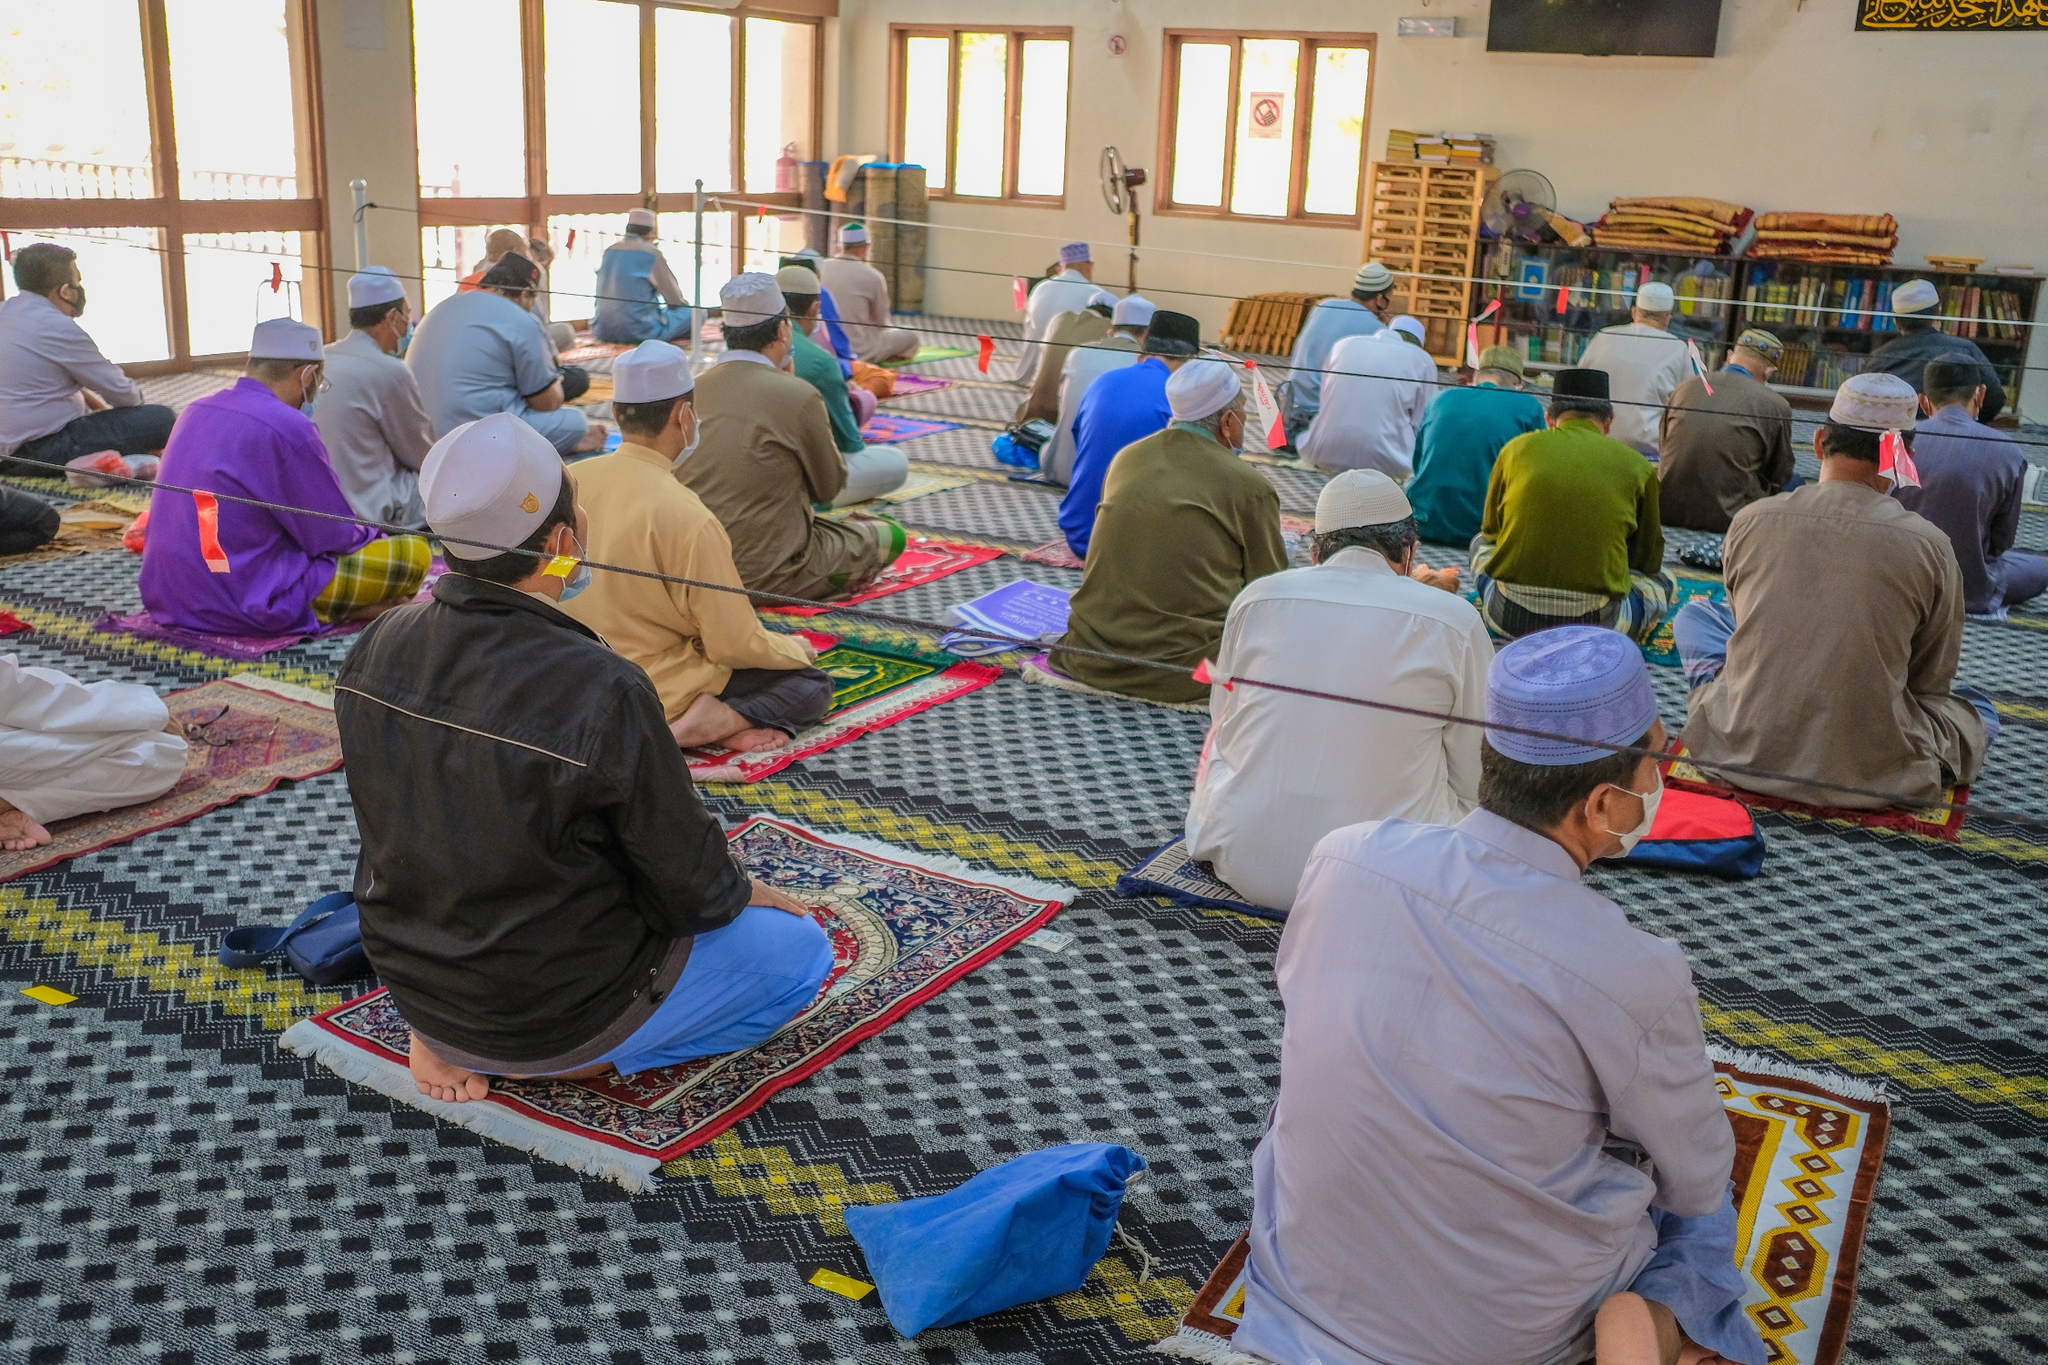What cultural significance can you draw from this image? The image reflects a rich tapestry of cultural significance. The act of communal prayer within the mosque is a key element in Islamic practice, embodying principles of unity, faith, and discipline. The use of prayer rugs, distinct seating arrangements, and traditional attire reflect deep-rooted customs and reverence for tradition. This scene not only highlights the collective spirituality of the community but also underscores the importance of preserving cultural rituals even amidst modern-day challenges. The bookshelves signify a dedication to knowledge and education, which are highly valued in the culture. How do the visual elements in the image contribute to the overall atmosphere? The visual elements in the image contribute significantly to the overall atmosphere of calm and devotion. The vibrant prayer rugs inject color and vibrancy, balancing the seriousness of the prayer session with visual warmth. The well-lit interior, thanks to the large windows, introduces a natural softness and openness to the room, enhancing the feeling of sanctuary. The orderly arrangement of the worshippers, their uniform direction, and the visible markers for maintaining social distance augment the sense of organized harmony and collective responsibility. The presence of bookshelves filled with texts epitomizes a quieter, intellectual pursuit that typically complements spiritual practices, adding depth to the scene. Imagine if this scene were part of a historical film. How would the filmmaker use lighting and color to enhance the storytelling? In a historical film, a filmmaker could use lighting and color to immensely enhance the storytelling of this scene. Soft, golden lighting streaming through the windows could symbolize divine presence and guidance, casting a warm glow over the worshippers to highlight their devoutness. Cooler tones might be used to accentuate the calm and contemplative nature of the moment, with the vibrant colors of the prayer rugs providing a contrast that ties tradition with piety. Shadows could be employed to add a layer of solemnity and reflection, while the bright daylight can showcase hope and spiritual purity. The meticulous use of these elements can transform the scene from a simple moment of prayer into a powerful portrayal of timeless faith and devotion. Place this image in a futuristic setting. What changes would you envision? Envisioning this image in a futuristic setting could present a fascinating juxtaposition of tradition and advanced technology. Perhaps the prayer rugs are made from smart fabrics that change colors or provide data on prayer times. The windows might have augmented reality displays showing celestial events or important religious texts. Congregants could be wearing garments embedded with wearable tech to monitor health and enhance comfort. The shelves could still be there, but with digitalized books and holographic displays enabling immersive reading experiences. The essence of unity and devotion would remain, but embraced within a high-tech environment that seamlessly blends the ancient with the cutting-edge, showcasing resilience and adaptability of cultural practices. What would it feel like to be in that room during prayer? Being in that room during prayer would likely be a profoundly serene and grounded experience. As you enter, the soft murmur of recitations would offer a calming backdrop, gently enveloping you in a cocoon of spirituality. The fragrance of carpets and the polished wooden shelves would blend subtly with the fresh air streaming in through the open windows. Sitting on a vibrant prayer rug, you’d instinctively fall into the rhythm of the communal movements, feeling a deep sense of unity with those around you. The sunlight washing over the space in gentle waves would make you feel at peace and connected, not just with the people present, but also with tradition and faith that run deep. Masks and distancing measures would remind you of collective care and responsibility, adding a layer of mutual respect and safety to your experience. 